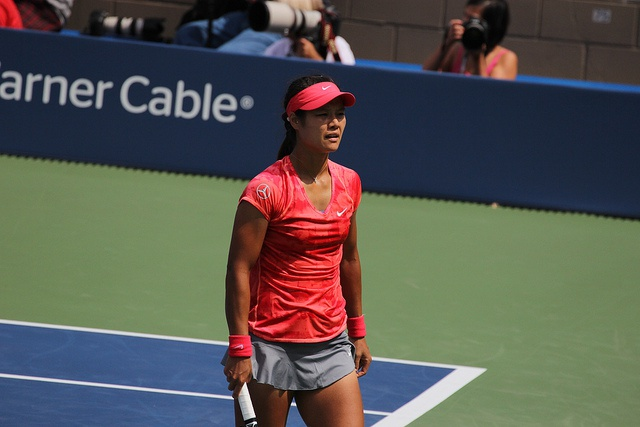Describe the objects in this image and their specific colors. I can see people in red, black, maroon, and salmon tones, people in red, black, maroon, and salmon tones, people in red, black, maroon, lavender, and brown tones, people in red, black, maroon, and gray tones, and tennis racket in red, lightgray, darkgray, black, and gray tones in this image. 